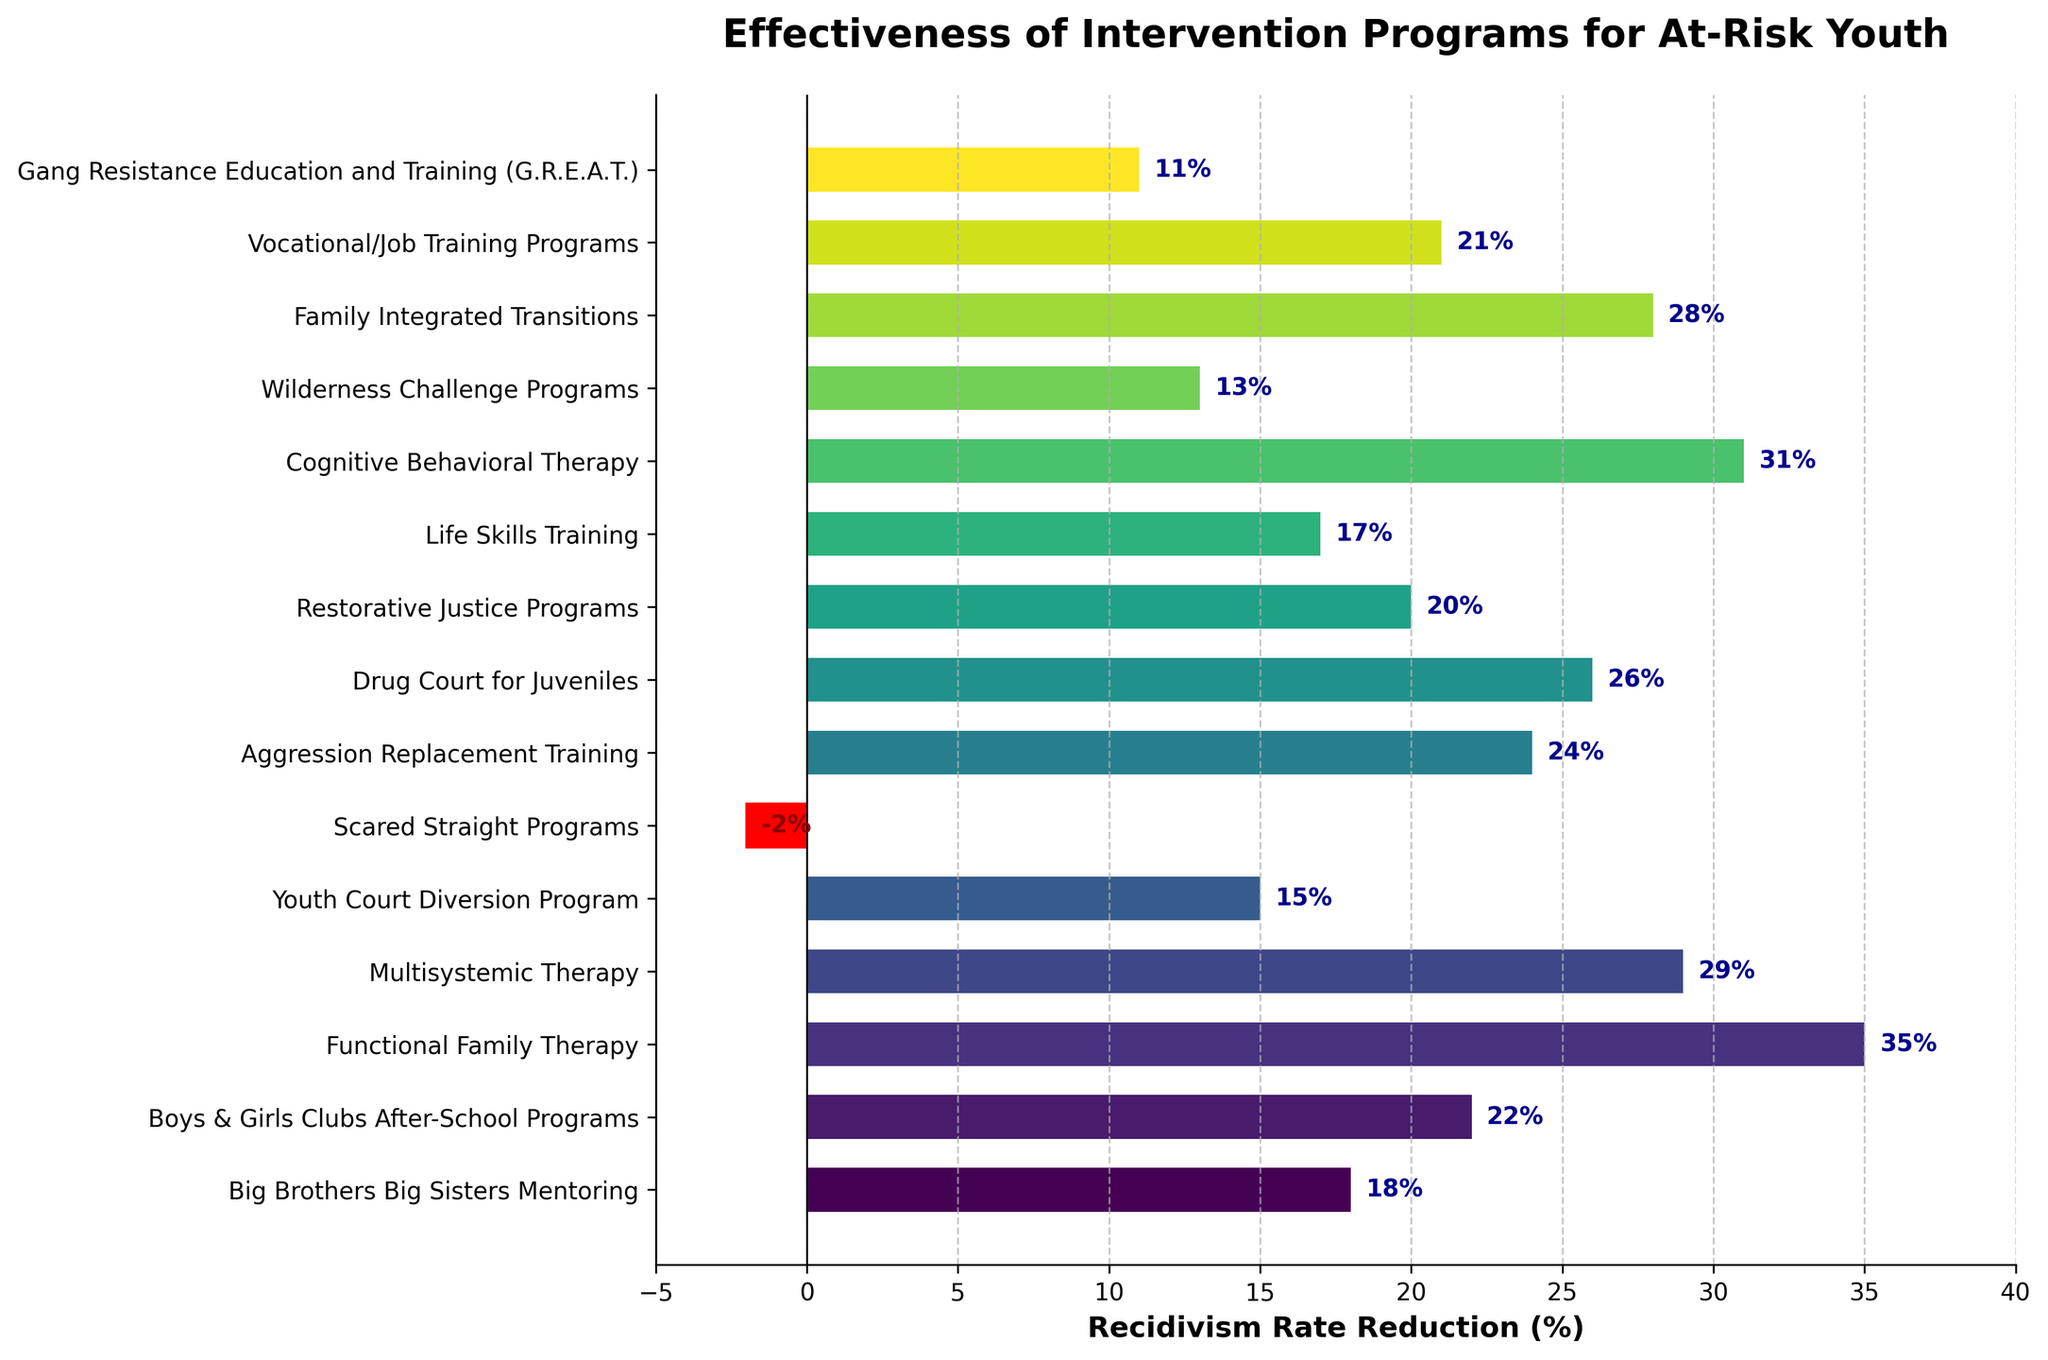What is the program with the highest recidivism rate reduction? The bar corresponding to Functional Family Therapy is the longest, representing the highest recidivism rate reduction of 35%.
Answer: Functional Family Therapy Which program has the lowest recidivism rate reduction? The Scared Straight Programs bar is the shortest and in red, indicating the lowest rate reduction of -2%.
Answer: Scared Straight Programs How many intervention programs have a recidivism rate reduction of more than 25%? Functional Family Therapy (35%), Multisystemic Therapy (29%), Drug Court for Juveniles (26%), and Cognitive Behavioral Therapy (31%) have rates greater than 25%, which totals to 4 programs.
Answer: 4 Which program has a 29% recidivism rate reduction? The bar corresponding to Multisystemic Therapy is marked with a 29% reduction.
Answer: Multisystemic Therapy What's the difference in recidivism rate reduction between Cognitive Behavioral Therapy and Scared Straight Programs? The recidivism rate for Cognitive Behavioral Therapy is 31%, and for Scared Straight Programs, it is -2%. The difference is 31% - (-2%) = 33%.
Answer: 33% Which programs have a recidivism rate reduction within the range of 15% to 20%? Youth Court Diversion Program (15%), Restorative Justice Programs (20%), and Life Skills Training (17%) fall within this range.
Answer: Youth Court Diversion Program, Restorative Justice Programs, Life Skills Training What's the average reduction rate across all intervention programs? Adding all the reductions (18 + 22 + 35 + 29 + 15 - 2 + 24 + 26 + 20 + 17 + 31 + 13 + 28 + 21 + 11) which totals to 308 and dividing by the number of programs (15), results in an average of 308/15.
Answer: 20.53% Compare the recidivism rate reductions of Aggression Replacement Training and Wilderness Challenge Programs. Which one is higher and by how much? Aggression Replacement Training has a reduction of 24%, Wilderness Challenge Programs has 13%. The difference is 24% - 13% = 11%.
Answer: Aggression Replacement Training by 11% Which programs have a negative recidivism rate reduction and how are they visually represented? Scared Straight Programs has a negative rate reduction, represented with a red colored bar.
Answer: Scared Straight Programs 